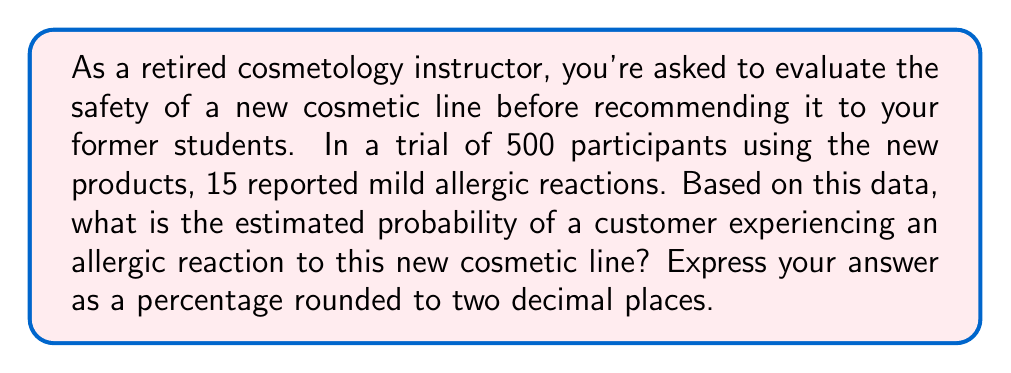What is the answer to this math problem? To estimate the probability of allergic reactions to the new cosmetic line, we need to use the given sample data to calculate the relative frequency of allergic reactions.

The steps to solve this problem are:

1. Identify the total number of participants: $n = 500$
2. Identify the number of participants who experienced allergic reactions: $x = 15$
3. Calculate the probability using the formula:

   $$ P(\text{allergic reaction}) = \frac{\text{number of allergic reactions}}{\text{total number of participants}} $$

4. Substitute the values:

   $$ P(\text{allergic reaction}) = \frac{15}{500} = 0.03 $$

5. Convert the probability to a percentage:

   $$ 0.03 \times 100\% = 3\% $$

Therefore, the estimated probability of a customer experiencing an allergic reaction to this new cosmetic line is 3.00%.
Answer: 3.00% 